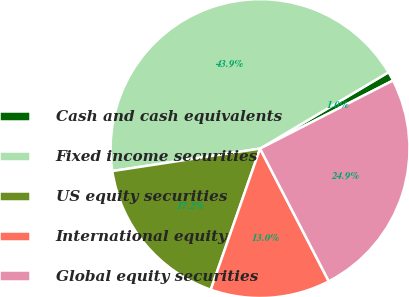<chart> <loc_0><loc_0><loc_500><loc_500><pie_chart><fcel>Cash and cash equivalents<fcel>Fixed income securities<fcel>US equity securities<fcel>International equity<fcel>Global equity securities<nl><fcel>1.0%<fcel>43.87%<fcel>17.25%<fcel>12.96%<fcel>24.93%<nl></chart> 